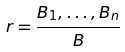Convert formula to latex. <formula><loc_0><loc_0><loc_500><loc_500>r = \frac { B _ { 1 } , \dots , B _ { n } } { B }</formula> 